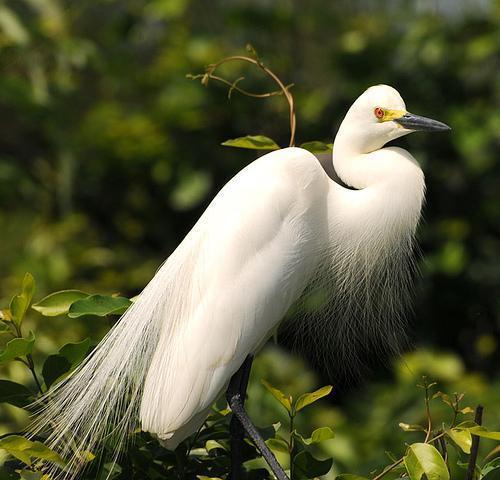How many people are pictured?
Give a very brief answer. 0. 